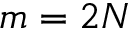<formula> <loc_0><loc_0><loc_500><loc_500>m = 2 N</formula> 